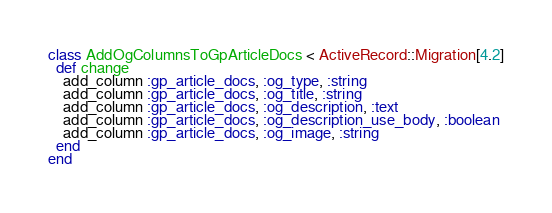Convert code to text. <code><loc_0><loc_0><loc_500><loc_500><_Ruby_>class AddOgColumnsToGpArticleDocs < ActiveRecord::Migration[4.2]
  def change
    add_column :gp_article_docs, :og_type, :string
    add_column :gp_article_docs, :og_title, :string
    add_column :gp_article_docs, :og_description, :text
    add_column :gp_article_docs, :og_description_use_body, :boolean
    add_column :gp_article_docs, :og_image, :string
  end
end
</code> 